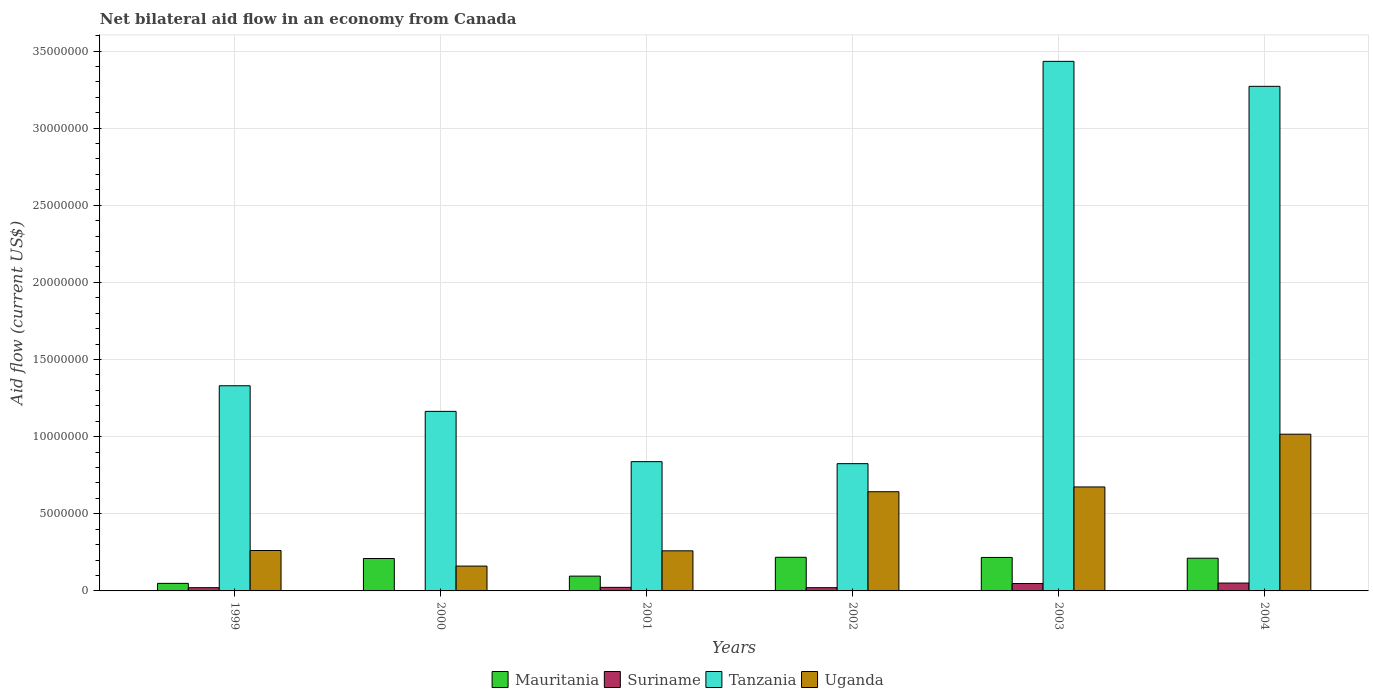Are the number of bars on each tick of the X-axis equal?
Provide a short and direct response. Yes. What is the label of the 1st group of bars from the left?
Keep it short and to the point. 1999. Across all years, what is the maximum net bilateral aid flow in Mauritania?
Offer a very short reply. 2.18e+06. In which year was the net bilateral aid flow in Tanzania minimum?
Make the answer very short. 2002. What is the total net bilateral aid flow in Suriname in the graph?
Provide a short and direct response. 1.65e+06. What is the difference between the net bilateral aid flow in Mauritania in 2001 and that in 2003?
Make the answer very short. -1.21e+06. What is the difference between the net bilateral aid flow in Suriname in 2001 and the net bilateral aid flow in Mauritania in 2002?
Give a very brief answer. -1.95e+06. What is the average net bilateral aid flow in Tanzania per year?
Ensure brevity in your answer.  1.81e+07. In the year 2000, what is the difference between the net bilateral aid flow in Mauritania and net bilateral aid flow in Suriname?
Make the answer very short. 2.09e+06. What is the ratio of the net bilateral aid flow in Mauritania in 2000 to that in 2001?
Give a very brief answer. 2.19. Is the net bilateral aid flow in Mauritania in 1999 less than that in 2001?
Give a very brief answer. Yes. What is the difference between the highest and the second highest net bilateral aid flow in Uganda?
Make the answer very short. 3.42e+06. What is the difference between the highest and the lowest net bilateral aid flow in Mauritania?
Your answer should be very brief. 1.69e+06. Is the sum of the net bilateral aid flow in Suriname in 2000 and 2002 greater than the maximum net bilateral aid flow in Mauritania across all years?
Ensure brevity in your answer.  No. What does the 2nd bar from the left in 2004 represents?
Give a very brief answer. Suriname. What does the 1st bar from the right in 2002 represents?
Ensure brevity in your answer.  Uganda. Is it the case that in every year, the sum of the net bilateral aid flow in Uganda and net bilateral aid flow in Mauritania is greater than the net bilateral aid flow in Tanzania?
Provide a succinct answer. No. How many bars are there?
Give a very brief answer. 24. Are all the bars in the graph horizontal?
Keep it short and to the point. No. What is the difference between two consecutive major ticks on the Y-axis?
Offer a very short reply. 5.00e+06. Where does the legend appear in the graph?
Make the answer very short. Bottom center. How many legend labels are there?
Ensure brevity in your answer.  4. What is the title of the graph?
Offer a very short reply. Net bilateral aid flow in an economy from Canada. Does "Iran" appear as one of the legend labels in the graph?
Ensure brevity in your answer.  No. What is the label or title of the X-axis?
Keep it short and to the point. Years. What is the label or title of the Y-axis?
Offer a very short reply. Aid flow (current US$). What is the Aid flow (current US$) of Suriname in 1999?
Give a very brief answer. 2.10e+05. What is the Aid flow (current US$) of Tanzania in 1999?
Your response must be concise. 1.33e+07. What is the Aid flow (current US$) in Uganda in 1999?
Offer a very short reply. 2.62e+06. What is the Aid flow (current US$) in Mauritania in 2000?
Your answer should be very brief. 2.10e+06. What is the Aid flow (current US$) of Tanzania in 2000?
Ensure brevity in your answer.  1.16e+07. What is the Aid flow (current US$) in Uganda in 2000?
Keep it short and to the point. 1.61e+06. What is the Aid flow (current US$) in Mauritania in 2001?
Give a very brief answer. 9.60e+05. What is the Aid flow (current US$) in Tanzania in 2001?
Your answer should be very brief. 8.38e+06. What is the Aid flow (current US$) in Uganda in 2001?
Provide a short and direct response. 2.60e+06. What is the Aid flow (current US$) in Mauritania in 2002?
Your answer should be very brief. 2.18e+06. What is the Aid flow (current US$) in Suriname in 2002?
Your answer should be very brief. 2.10e+05. What is the Aid flow (current US$) of Tanzania in 2002?
Offer a very short reply. 8.25e+06. What is the Aid flow (current US$) of Uganda in 2002?
Offer a very short reply. 6.43e+06. What is the Aid flow (current US$) in Mauritania in 2003?
Keep it short and to the point. 2.17e+06. What is the Aid flow (current US$) of Suriname in 2003?
Make the answer very short. 4.80e+05. What is the Aid flow (current US$) in Tanzania in 2003?
Provide a short and direct response. 3.43e+07. What is the Aid flow (current US$) in Uganda in 2003?
Ensure brevity in your answer.  6.74e+06. What is the Aid flow (current US$) of Mauritania in 2004?
Offer a terse response. 2.12e+06. What is the Aid flow (current US$) in Suriname in 2004?
Offer a very short reply. 5.10e+05. What is the Aid flow (current US$) of Tanzania in 2004?
Keep it short and to the point. 3.27e+07. What is the Aid flow (current US$) of Uganda in 2004?
Offer a very short reply. 1.02e+07. Across all years, what is the maximum Aid flow (current US$) of Mauritania?
Make the answer very short. 2.18e+06. Across all years, what is the maximum Aid flow (current US$) in Suriname?
Your response must be concise. 5.10e+05. Across all years, what is the maximum Aid flow (current US$) in Tanzania?
Your answer should be compact. 3.43e+07. Across all years, what is the maximum Aid flow (current US$) of Uganda?
Make the answer very short. 1.02e+07. Across all years, what is the minimum Aid flow (current US$) of Mauritania?
Your answer should be compact. 4.90e+05. Across all years, what is the minimum Aid flow (current US$) of Tanzania?
Keep it short and to the point. 8.25e+06. Across all years, what is the minimum Aid flow (current US$) in Uganda?
Give a very brief answer. 1.61e+06. What is the total Aid flow (current US$) of Mauritania in the graph?
Make the answer very short. 1.00e+07. What is the total Aid flow (current US$) in Suriname in the graph?
Make the answer very short. 1.65e+06. What is the total Aid flow (current US$) of Tanzania in the graph?
Provide a short and direct response. 1.09e+08. What is the total Aid flow (current US$) in Uganda in the graph?
Make the answer very short. 3.02e+07. What is the difference between the Aid flow (current US$) of Mauritania in 1999 and that in 2000?
Your response must be concise. -1.61e+06. What is the difference between the Aid flow (current US$) of Tanzania in 1999 and that in 2000?
Provide a short and direct response. 1.66e+06. What is the difference between the Aid flow (current US$) of Uganda in 1999 and that in 2000?
Provide a succinct answer. 1.01e+06. What is the difference between the Aid flow (current US$) of Mauritania in 1999 and that in 2001?
Your answer should be compact. -4.70e+05. What is the difference between the Aid flow (current US$) in Suriname in 1999 and that in 2001?
Make the answer very short. -2.00e+04. What is the difference between the Aid flow (current US$) of Tanzania in 1999 and that in 2001?
Ensure brevity in your answer.  4.92e+06. What is the difference between the Aid flow (current US$) of Mauritania in 1999 and that in 2002?
Make the answer very short. -1.69e+06. What is the difference between the Aid flow (current US$) of Tanzania in 1999 and that in 2002?
Give a very brief answer. 5.05e+06. What is the difference between the Aid flow (current US$) of Uganda in 1999 and that in 2002?
Ensure brevity in your answer.  -3.81e+06. What is the difference between the Aid flow (current US$) in Mauritania in 1999 and that in 2003?
Your response must be concise. -1.68e+06. What is the difference between the Aid flow (current US$) in Suriname in 1999 and that in 2003?
Give a very brief answer. -2.70e+05. What is the difference between the Aid flow (current US$) in Tanzania in 1999 and that in 2003?
Your response must be concise. -2.10e+07. What is the difference between the Aid flow (current US$) in Uganda in 1999 and that in 2003?
Make the answer very short. -4.12e+06. What is the difference between the Aid flow (current US$) of Mauritania in 1999 and that in 2004?
Offer a very short reply. -1.63e+06. What is the difference between the Aid flow (current US$) of Suriname in 1999 and that in 2004?
Offer a very short reply. -3.00e+05. What is the difference between the Aid flow (current US$) in Tanzania in 1999 and that in 2004?
Your response must be concise. -1.94e+07. What is the difference between the Aid flow (current US$) in Uganda in 1999 and that in 2004?
Offer a terse response. -7.54e+06. What is the difference between the Aid flow (current US$) in Mauritania in 2000 and that in 2001?
Ensure brevity in your answer.  1.14e+06. What is the difference between the Aid flow (current US$) in Suriname in 2000 and that in 2001?
Ensure brevity in your answer.  -2.20e+05. What is the difference between the Aid flow (current US$) in Tanzania in 2000 and that in 2001?
Offer a very short reply. 3.26e+06. What is the difference between the Aid flow (current US$) in Uganda in 2000 and that in 2001?
Your answer should be very brief. -9.90e+05. What is the difference between the Aid flow (current US$) of Mauritania in 2000 and that in 2002?
Keep it short and to the point. -8.00e+04. What is the difference between the Aid flow (current US$) in Suriname in 2000 and that in 2002?
Provide a succinct answer. -2.00e+05. What is the difference between the Aid flow (current US$) of Tanzania in 2000 and that in 2002?
Offer a very short reply. 3.39e+06. What is the difference between the Aid flow (current US$) in Uganda in 2000 and that in 2002?
Your response must be concise. -4.82e+06. What is the difference between the Aid flow (current US$) in Mauritania in 2000 and that in 2003?
Offer a very short reply. -7.00e+04. What is the difference between the Aid flow (current US$) of Suriname in 2000 and that in 2003?
Ensure brevity in your answer.  -4.70e+05. What is the difference between the Aid flow (current US$) in Tanzania in 2000 and that in 2003?
Offer a terse response. -2.27e+07. What is the difference between the Aid flow (current US$) of Uganda in 2000 and that in 2003?
Provide a short and direct response. -5.13e+06. What is the difference between the Aid flow (current US$) in Suriname in 2000 and that in 2004?
Keep it short and to the point. -5.00e+05. What is the difference between the Aid flow (current US$) of Tanzania in 2000 and that in 2004?
Offer a terse response. -2.11e+07. What is the difference between the Aid flow (current US$) in Uganda in 2000 and that in 2004?
Offer a very short reply. -8.55e+06. What is the difference between the Aid flow (current US$) of Mauritania in 2001 and that in 2002?
Provide a short and direct response. -1.22e+06. What is the difference between the Aid flow (current US$) of Suriname in 2001 and that in 2002?
Provide a succinct answer. 2.00e+04. What is the difference between the Aid flow (current US$) of Tanzania in 2001 and that in 2002?
Ensure brevity in your answer.  1.30e+05. What is the difference between the Aid flow (current US$) in Uganda in 2001 and that in 2002?
Give a very brief answer. -3.83e+06. What is the difference between the Aid flow (current US$) of Mauritania in 2001 and that in 2003?
Offer a very short reply. -1.21e+06. What is the difference between the Aid flow (current US$) of Tanzania in 2001 and that in 2003?
Your response must be concise. -2.60e+07. What is the difference between the Aid flow (current US$) in Uganda in 2001 and that in 2003?
Offer a very short reply. -4.14e+06. What is the difference between the Aid flow (current US$) of Mauritania in 2001 and that in 2004?
Offer a very short reply. -1.16e+06. What is the difference between the Aid flow (current US$) of Suriname in 2001 and that in 2004?
Keep it short and to the point. -2.80e+05. What is the difference between the Aid flow (current US$) of Tanzania in 2001 and that in 2004?
Make the answer very short. -2.43e+07. What is the difference between the Aid flow (current US$) in Uganda in 2001 and that in 2004?
Provide a short and direct response. -7.56e+06. What is the difference between the Aid flow (current US$) of Tanzania in 2002 and that in 2003?
Make the answer very short. -2.61e+07. What is the difference between the Aid flow (current US$) in Uganda in 2002 and that in 2003?
Your answer should be very brief. -3.10e+05. What is the difference between the Aid flow (current US$) of Tanzania in 2002 and that in 2004?
Offer a very short reply. -2.45e+07. What is the difference between the Aid flow (current US$) of Uganda in 2002 and that in 2004?
Make the answer very short. -3.73e+06. What is the difference between the Aid flow (current US$) in Suriname in 2003 and that in 2004?
Your answer should be compact. -3.00e+04. What is the difference between the Aid flow (current US$) in Tanzania in 2003 and that in 2004?
Your answer should be compact. 1.62e+06. What is the difference between the Aid flow (current US$) of Uganda in 2003 and that in 2004?
Ensure brevity in your answer.  -3.42e+06. What is the difference between the Aid flow (current US$) of Mauritania in 1999 and the Aid flow (current US$) of Suriname in 2000?
Provide a succinct answer. 4.80e+05. What is the difference between the Aid flow (current US$) in Mauritania in 1999 and the Aid flow (current US$) in Tanzania in 2000?
Your response must be concise. -1.12e+07. What is the difference between the Aid flow (current US$) in Mauritania in 1999 and the Aid flow (current US$) in Uganda in 2000?
Make the answer very short. -1.12e+06. What is the difference between the Aid flow (current US$) of Suriname in 1999 and the Aid flow (current US$) of Tanzania in 2000?
Provide a short and direct response. -1.14e+07. What is the difference between the Aid flow (current US$) in Suriname in 1999 and the Aid flow (current US$) in Uganda in 2000?
Provide a short and direct response. -1.40e+06. What is the difference between the Aid flow (current US$) of Tanzania in 1999 and the Aid flow (current US$) of Uganda in 2000?
Your answer should be very brief. 1.17e+07. What is the difference between the Aid flow (current US$) of Mauritania in 1999 and the Aid flow (current US$) of Suriname in 2001?
Keep it short and to the point. 2.60e+05. What is the difference between the Aid flow (current US$) of Mauritania in 1999 and the Aid flow (current US$) of Tanzania in 2001?
Your answer should be compact. -7.89e+06. What is the difference between the Aid flow (current US$) of Mauritania in 1999 and the Aid flow (current US$) of Uganda in 2001?
Give a very brief answer. -2.11e+06. What is the difference between the Aid flow (current US$) of Suriname in 1999 and the Aid flow (current US$) of Tanzania in 2001?
Offer a very short reply. -8.17e+06. What is the difference between the Aid flow (current US$) of Suriname in 1999 and the Aid flow (current US$) of Uganda in 2001?
Provide a short and direct response. -2.39e+06. What is the difference between the Aid flow (current US$) in Tanzania in 1999 and the Aid flow (current US$) in Uganda in 2001?
Ensure brevity in your answer.  1.07e+07. What is the difference between the Aid flow (current US$) in Mauritania in 1999 and the Aid flow (current US$) in Tanzania in 2002?
Ensure brevity in your answer.  -7.76e+06. What is the difference between the Aid flow (current US$) of Mauritania in 1999 and the Aid flow (current US$) of Uganda in 2002?
Ensure brevity in your answer.  -5.94e+06. What is the difference between the Aid flow (current US$) in Suriname in 1999 and the Aid flow (current US$) in Tanzania in 2002?
Provide a short and direct response. -8.04e+06. What is the difference between the Aid flow (current US$) in Suriname in 1999 and the Aid flow (current US$) in Uganda in 2002?
Provide a succinct answer. -6.22e+06. What is the difference between the Aid flow (current US$) of Tanzania in 1999 and the Aid flow (current US$) of Uganda in 2002?
Keep it short and to the point. 6.87e+06. What is the difference between the Aid flow (current US$) in Mauritania in 1999 and the Aid flow (current US$) in Tanzania in 2003?
Give a very brief answer. -3.38e+07. What is the difference between the Aid flow (current US$) in Mauritania in 1999 and the Aid flow (current US$) in Uganda in 2003?
Ensure brevity in your answer.  -6.25e+06. What is the difference between the Aid flow (current US$) in Suriname in 1999 and the Aid flow (current US$) in Tanzania in 2003?
Give a very brief answer. -3.41e+07. What is the difference between the Aid flow (current US$) in Suriname in 1999 and the Aid flow (current US$) in Uganda in 2003?
Keep it short and to the point. -6.53e+06. What is the difference between the Aid flow (current US$) of Tanzania in 1999 and the Aid flow (current US$) of Uganda in 2003?
Keep it short and to the point. 6.56e+06. What is the difference between the Aid flow (current US$) of Mauritania in 1999 and the Aid flow (current US$) of Suriname in 2004?
Give a very brief answer. -2.00e+04. What is the difference between the Aid flow (current US$) of Mauritania in 1999 and the Aid flow (current US$) of Tanzania in 2004?
Offer a very short reply. -3.22e+07. What is the difference between the Aid flow (current US$) of Mauritania in 1999 and the Aid flow (current US$) of Uganda in 2004?
Give a very brief answer. -9.67e+06. What is the difference between the Aid flow (current US$) of Suriname in 1999 and the Aid flow (current US$) of Tanzania in 2004?
Your answer should be very brief. -3.25e+07. What is the difference between the Aid flow (current US$) of Suriname in 1999 and the Aid flow (current US$) of Uganda in 2004?
Give a very brief answer. -9.95e+06. What is the difference between the Aid flow (current US$) in Tanzania in 1999 and the Aid flow (current US$) in Uganda in 2004?
Your answer should be compact. 3.14e+06. What is the difference between the Aid flow (current US$) of Mauritania in 2000 and the Aid flow (current US$) of Suriname in 2001?
Offer a terse response. 1.87e+06. What is the difference between the Aid flow (current US$) of Mauritania in 2000 and the Aid flow (current US$) of Tanzania in 2001?
Your answer should be very brief. -6.28e+06. What is the difference between the Aid flow (current US$) in Mauritania in 2000 and the Aid flow (current US$) in Uganda in 2001?
Your response must be concise. -5.00e+05. What is the difference between the Aid flow (current US$) of Suriname in 2000 and the Aid flow (current US$) of Tanzania in 2001?
Ensure brevity in your answer.  -8.37e+06. What is the difference between the Aid flow (current US$) of Suriname in 2000 and the Aid flow (current US$) of Uganda in 2001?
Your answer should be compact. -2.59e+06. What is the difference between the Aid flow (current US$) in Tanzania in 2000 and the Aid flow (current US$) in Uganda in 2001?
Your answer should be very brief. 9.04e+06. What is the difference between the Aid flow (current US$) in Mauritania in 2000 and the Aid flow (current US$) in Suriname in 2002?
Give a very brief answer. 1.89e+06. What is the difference between the Aid flow (current US$) in Mauritania in 2000 and the Aid flow (current US$) in Tanzania in 2002?
Offer a very short reply. -6.15e+06. What is the difference between the Aid flow (current US$) in Mauritania in 2000 and the Aid flow (current US$) in Uganda in 2002?
Offer a terse response. -4.33e+06. What is the difference between the Aid flow (current US$) in Suriname in 2000 and the Aid flow (current US$) in Tanzania in 2002?
Offer a terse response. -8.24e+06. What is the difference between the Aid flow (current US$) in Suriname in 2000 and the Aid flow (current US$) in Uganda in 2002?
Your response must be concise. -6.42e+06. What is the difference between the Aid flow (current US$) of Tanzania in 2000 and the Aid flow (current US$) of Uganda in 2002?
Provide a succinct answer. 5.21e+06. What is the difference between the Aid flow (current US$) in Mauritania in 2000 and the Aid flow (current US$) in Suriname in 2003?
Offer a very short reply. 1.62e+06. What is the difference between the Aid flow (current US$) of Mauritania in 2000 and the Aid flow (current US$) of Tanzania in 2003?
Provide a succinct answer. -3.22e+07. What is the difference between the Aid flow (current US$) in Mauritania in 2000 and the Aid flow (current US$) in Uganda in 2003?
Offer a terse response. -4.64e+06. What is the difference between the Aid flow (current US$) in Suriname in 2000 and the Aid flow (current US$) in Tanzania in 2003?
Keep it short and to the point. -3.43e+07. What is the difference between the Aid flow (current US$) in Suriname in 2000 and the Aid flow (current US$) in Uganda in 2003?
Your response must be concise. -6.73e+06. What is the difference between the Aid flow (current US$) of Tanzania in 2000 and the Aid flow (current US$) of Uganda in 2003?
Provide a short and direct response. 4.90e+06. What is the difference between the Aid flow (current US$) of Mauritania in 2000 and the Aid flow (current US$) of Suriname in 2004?
Your answer should be compact. 1.59e+06. What is the difference between the Aid flow (current US$) of Mauritania in 2000 and the Aid flow (current US$) of Tanzania in 2004?
Ensure brevity in your answer.  -3.06e+07. What is the difference between the Aid flow (current US$) in Mauritania in 2000 and the Aid flow (current US$) in Uganda in 2004?
Offer a very short reply. -8.06e+06. What is the difference between the Aid flow (current US$) of Suriname in 2000 and the Aid flow (current US$) of Tanzania in 2004?
Offer a terse response. -3.27e+07. What is the difference between the Aid flow (current US$) in Suriname in 2000 and the Aid flow (current US$) in Uganda in 2004?
Make the answer very short. -1.02e+07. What is the difference between the Aid flow (current US$) of Tanzania in 2000 and the Aid flow (current US$) of Uganda in 2004?
Your answer should be very brief. 1.48e+06. What is the difference between the Aid flow (current US$) in Mauritania in 2001 and the Aid flow (current US$) in Suriname in 2002?
Provide a succinct answer. 7.50e+05. What is the difference between the Aid flow (current US$) in Mauritania in 2001 and the Aid flow (current US$) in Tanzania in 2002?
Give a very brief answer. -7.29e+06. What is the difference between the Aid flow (current US$) of Mauritania in 2001 and the Aid flow (current US$) of Uganda in 2002?
Keep it short and to the point. -5.47e+06. What is the difference between the Aid flow (current US$) of Suriname in 2001 and the Aid flow (current US$) of Tanzania in 2002?
Ensure brevity in your answer.  -8.02e+06. What is the difference between the Aid flow (current US$) of Suriname in 2001 and the Aid flow (current US$) of Uganda in 2002?
Provide a short and direct response. -6.20e+06. What is the difference between the Aid flow (current US$) in Tanzania in 2001 and the Aid flow (current US$) in Uganda in 2002?
Provide a short and direct response. 1.95e+06. What is the difference between the Aid flow (current US$) of Mauritania in 2001 and the Aid flow (current US$) of Tanzania in 2003?
Offer a terse response. -3.34e+07. What is the difference between the Aid flow (current US$) in Mauritania in 2001 and the Aid flow (current US$) in Uganda in 2003?
Your response must be concise. -5.78e+06. What is the difference between the Aid flow (current US$) in Suriname in 2001 and the Aid flow (current US$) in Tanzania in 2003?
Keep it short and to the point. -3.41e+07. What is the difference between the Aid flow (current US$) in Suriname in 2001 and the Aid flow (current US$) in Uganda in 2003?
Provide a short and direct response. -6.51e+06. What is the difference between the Aid flow (current US$) in Tanzania in 2001 and the Aid flow (current US$) in Uganda in 2003?
Offer a very short reply. 1.64e+06. What is the difference between the Aid flow (current US$) in Mauritania in 2001 and the Aid flow (current US$) in Suriname in 2004?
Offer a terse response. 4.50e+05. What is the difference between the Aid flow (current US$) in Mauritania in 2001 and the Aid flow (current US$) in Tanzania in 2004?
Offer a very short reply. -3.18e+07. What is the difference between the Aid flow (current US$) of Mauritania in 2001 and the Aid flow (current US$) of Uganda in 2004?
Your answer should be very brief. -9.20e+06. What is the difference between the Aid flow (current US$) of Suriname in 2001 and the Aid flow (current US$) of Tanzania in 2004?
Offer a very short reply. -3.25e+07. What is the difference between the Aid flow (current US$) of Suriname in 2001 and the Aid flow (current US$) of Uganda in 2004?
Provide a succinct answer. -9.93e+06. What is the difference between the Aid flow (current US$) in Tanzania in 2001 and the Aid flow (current US$) in Uganda in 2004?
Keep it short and to the point. -1.78e+06. What is the difference between the Aid flow (current US$) in Mauritania in 2002 and the Aid flow (current US$) in Suriname in 2003?
Your answer should be compact. 1.70e+06. What is the difference between the Aid flow (current US$) of Mauritania in 2002 and the Aid flow (current US$) of Tanzania in 2003?
Provide a succinct answer. -3.22e+07. What is the difference between the Aid flow (current US$) in Mauritania in 2002 and the Aid flow (current US$) in Uganda in 2003?
Give a very brief answer. -4.56e+06. What is the difference between the Aid flow (current US$) of Suriname in 2002 and the Aid flow (current US$) of Tanzania in 2003?
Make the answer very short. -3.41e+07. What is the difference between the Aid flow (current US$) in Suriname in 2002 and the Aid flow (current US$) in Uganda in 2003?
Provide a succinct answer. -6.53e+06. What is the difference between the Aid flow (current US$) of Tanzania in 2002 and the Aid flow (current US$) of Uganda in 2003?
Your answer should be very brief. 1.51e+06. What is the difference between the Aid flow (current US$) of Mauritania in 2002 and the Aid flow (current US$) of Suriname in 2004?
Provide a succinct answer. 1.67e+06. What is the difference between the Aid flow (current US$) of Mauritania in 2002 and the Aid flow (current US$) of Tanzania in 2004?
Make the answer very short. -3.05e+07. What is the difference between the Aid flow (current US$) of Mauritania in 2002 and the Aid flow (current US$) of Uganda in 2004?
Provide a short and direct response. -7.98e+06. What is the difference between the Aid flow (current US$) of Suriname in 2002 and the Aid flow (current US$) of Tanzania in 2004?
Keep it short and to the point. -3.25e+07. What is the difference between the Aid flow (current US$) of Suriname in 2002 and the Aid flow (current US$) of Uganda in 2004?
Offer a very short reply. -9.95e+06. What is the difference between the Aid flow (current US$) in Tanzania in 2002 and the Aid flow (current US$) in Uganda in 2004?
Provide a succinct answer. -1.91e+06. What is the difference between the Aid flow (current US$) of Mauritania in 2003 and the Aid flow (current US$) of Suriname in 2004?
Ensure brevity in your answer.  1.66e+06. What is the difference between the Aid flow (current US$) of Mauritania in 2003 and the Aid flow (current US$) of Tanzania in 2004?
Ensure brevity in your answer.  -3.05e+07. What is the difference between the Aid flow (current US$) in Mauritania in 2003 and the Aid flow (current US$) in Uganda in 2004?
Your answer should be compact. -7.99e+06. What is the difference between the Aid flow (current US$) of Suriname in 2003 and the Aid flow (current US$) of Tanzania in 2004?
Provide a short and direct response. -3.22e+07. What is the difference between the Aid flow (current US$) in Suriname in 2003 and the Aid flow (current US$) in Uganda in 2004?
Keep it short and to the point. -9.68e+06. What is the difference between the Aid flow (current US$) in Tanzania in 2003 and the Aid flow (current US$) in Uganda in 2004?
Your answer should be compact. 2.42e+07. What is the average Aid flow (current US$) of Mauritania per year?
Offer a terse response. 1.67e+06. What is the average Aid flow (current US$) of Suriname per year?
Keep it short and to the point. 2.75e+05. What is the average Aid flow (current US$) in Tanzania per year?
Offer a very short reply. 1.81e+07. What is the average Aid flow (current US$) in Uganda per year?
Provide a short and direct response. 5.03e+06. In the year 1999, what is the difference between the Aid flow (current US$) in Mauritania and Aid flow (current US$) in Suriname?
Your response must be concise. 2.80e+05. In the year 1999, what is the difference between the Aid flow (current US$) in Mauritania and Aid flow (current US$) in Tanzania?
Your answer should be compact. -1.28e+07. In the year 1999, what is the difference between the Aid flow (current US$) in Mauritania and Aid flow (current US$) in Uganda?
Offer a very short reply. -2.13e+06. In the year 1999, what is the difference between the Aid flow (current US$) of Suriname and Aid flow (current US$) of Tanzania?
Ensure brevity in your answer.  -1.31e+07. In the year 1999, what is the difference between the Aid flow (current US$) in Suriname and Aid flow (current US$) in Uganda?
Your answer should be very brief. -2.41e+06. In the year 1999, what is the difference between the Aid flow (current US$) in Tanzania and Aid flow (current US$) in Uganda?
Provide a succinct answer. 1.07e+07. In the year 2000, what is the difference between the Aid flow (current US$) in Mauritania and Aid flow (current US$) in Suriname?
Offer a very short reply. 2.09e+06. In the year 2000, what is the difference between the Aid flow (current US$) in Mauritania and Aid flow (current US$) in Tanzania?
Your answer should be compact. -9.54e+06. In the year 2000, what is the difference between the Aid flow (current US$) in Suriname and Aid flow (current US$) in Tanzania?
Offer a very short reply. -1.16e+07. In the year 2000, what is the difference between the Aid flow (current US$) of Suriname and Aid flow (current US$) of Uganda?
Your answer should be very brief. -1.60e+06. In the year 2000, what is the difference between the Aid flow (current US$) of Tanzania and Aid flow (current US$) of Uganda?
Your answer should be very brief. 1.00e+07. In the year 2001, what is the difference between the Aid flow (current US$) of Mauritania and Aid flow (current US$) of Suriname?
Offer a very short reply. 7.30e+05. In the year 2001, what is the difference between the Aid flow (current US$) of Mauritania and Aid flow (current US$) of Tanzania?
Provide a succinct answer. -7.42e+06. In the year 2001, what is the difference between the Aid flow (current US$) of Mauritania and Aid flow (current US$) of Uganda?
Make the answer very short. -1.64e+06. In the year 2001, what is the difference between the Aid flow (current US$) of Suriname and Aid flow (current US$) of Tanzania?
Offer a terse response. -8.15e+06. In the year 2001, what is the difference between the Aid flow (current US$) of Suriname and Aid flow (current US$) of Uganda?
Your answer should be very brief. -2.37e+06. In the year 2001, what is the difference between the Aid flow (current US$) of Tanzania and Aid flow (current US$) of Uganda?
Your answer should be compact. 5.78e+06. In the year 2002, what is the difference between the Aid flow (current US$) of Mauritania and Aid flow (current US$) of Suriname?
Offer a very short reply. 1.97e+06. In the year 2002, what is the difference between the Aid flow (current US$) of Mauritania and Aid flow (current US$) of Tanzania?
Your answer should be compact. -6.07e+06. In the year 2002, what is the difference between the Aid flow (current US$) of Mauritania and Aid flow (current US$) of Uganda?
Keep it short and to the point. -4.25e+06. In the year 2002, what is the difference between the Aid flow (current US$) in Suriname and Aid flow (current US$) in Tanzania?
Provide a succinct answer. -8.04e+06. In the year 2002, what is the difference between the Aid flow (current US$) of Suriname and Aid flow (current US$) of Uganda?
Provide a succinct answer. -6.22e+06. In the year 2002, what is the difference between the Aid flow (current US$) of Tanzania and Aid flow (current US$) of Uganda?
Your answer should be compact. 1.82e+06. In the year 2003, what is the difference between the Aid flow (current US$) in Mauritania and Aid flow (current US$) in Suriname?
Your answer should be compact. 1.69e+06. In the year 2003, what is the difference between the Aid flow (current US$) in Mauritania and Aid flow (current US$) in Tanzania?
Your answer should be very brief. -3.22e+07. In the year 2003, what is the difference between the Aid flow (current US$) in Mauritania and Aid flow (current US$) in Uganda?
Your answer should be compact. -4.57e+06. In the year 2003, what is the difference between the Aid flow (current US$) of Suriname and Aid flow (current US$) of Tanzania?
Offer a very short reply. -3.38e+07. In the year 2003, what is the difference between the Aid flow (current US$) in Suriname and Aid flow (current US$) in Uganda?
Offer a terse response. -6.26e+06. In the year 2003, what is the difference between the Aid flow (current US$) in Tanzania and Aid flow (current US$) in Uganda?
Give a very brief answer. 2.76e+07. In the year 2004, what is the difference between the Aid flow (current US$) of Mauritania and Aid flow (current US$) of Suriname?
Offer a terse response. 1.61e+06. In the year 2004, what is the difference between the Aid flow (current US$) of Mauritania and Aid flow (current US$) of Tanzania?
Your answer should be compact. -3.06e+07. In the year 2004, what is the difference between the Aid flow (current US$) in Mauritania and Aid flow (current US$) in Uganda?
Provide a succinct answer. -8.04e+06. In the year 2004, what is the difference between the Aid flow (current US$) in Suriname and Aid flow (current US$) in Tanzania?
Keep it short and to the point. -3.22e+07. In the year 2004, what is the difference between the Aid flow (current US$) of Suriname and Aid flow (current US$) of Uganda?
Ensure brevity in your answer.  -9.65e+06. In the year 2004, what is the difference between the Aid flow (current US$) of Tanzania and Aid flow (current US$) of Uganda?
Make the answer very short. 2.26e+07. What is the ratio of the Aid flow (current US$) in Mauritania in 1999 to that in 2000?
Ensure brevity in your answer.  0.23. What is the ratio of the Aid flow (current US$) in Suriname in 1999 to that in 2000?
Offer a very short reply. 21. What is the ratio of the Aid flow (current US$) in Tanzania in 1999 to that in 2000?
Provide a short and direct response. 1.14. What is the ratio of the Aid flow (current US$) of Uganda in 1999 to that in 2000?
Ensure brevity in your answer.  1.63. What is the ratio of the Aid flow (current US$) of Mauritania in 1999 to that in 2001?
Your response must be concise. 0.51. What is the ratio of the Aid flow (current US$) in Tanzania in 1999 to that in 2001?
Provide a succinct answer. 1.59. What is the ratio of the Aid flow (current US$) in Uganda in 1999 to that in 2001?
Provide a succinct answer. 1.01. What is the ratio of the Aid flow (current US$) in Mauritania in 1999 to that in 2002?
Your answer should be compact. 0.22. What is the ratio of the Aid flow (current US$) in Suriname in 1999 to that in 2002?
Offer a terse response. 1. What is the ratio of the Aid flow (current US$) in Tanzania in 1999 to that in 2002?
Keep it short and to the point. 1.61. What is the ratio of the Aid flow (current US$) of Uganda in 1999 to that in 2002?
Your answer should be compact. 0.41. What is the ratio of the Aid flow (current US$) of Mauritania in 1999 to that in 2003?
Your answer should be compact. 0.23. What is the ratio of the Aid flow (current US$) in Suriname in 1999 to that in 2003?
Offer a terse response. 0.44. What is the ratio of the Aid flow (current US$) of Tanzania in 1999 to that in 2003?
Provide a short and direct response. 0.39. What is the ratio of the Aid flow (current US$) in Uganda in 1999 to that in 2003?
Provide a short and direct response. 0.39. What is the ratio of the Aid flow (current US$) of Mauritania in 1999 to that in 2004?
Keep it short and to the point. 0.23. What is the ratio of the Aid flow (current US$) of Suriname in 1999 to that in 2004?
Provide a succinct answer. 0.41. What is the ratio of the Aid flow (current US$) in Tanzania in 1999 to that in 2004?
Your answer should be compact. 0.41. What is the ratio of the Aid flow (current US$) in Uganda in 1999 to that in 2004?
Provide a short and direct response. 0.26. What is the ratio of the Aid flow (current US$) of Mauritania in 2000 to that in 2001?
Your answer should be compact. 2.19. What is the ratio of the Aid flow (current US$) of Suriname in 2000 to that in 2001?
Your answer should be very brief. 0.04. What is the ratio of the Aid flow (current US$) in Tanzania in 2000 to that in 2001?
Offer a very short reply. 1.39. What is the ratio of the Aid flow (current US$) of Uganda in 2000 to that in 2001?
Provide a short and direct response. 0.62. What is the ratio of the Aid flow (current US$) in Mauritania in 2000 to that in 2002?
Offer a very short reply. 0.96. What is the ratio of the Aid flow (current US$) of Suriname in 2000 to that in 2002?
Ensure brevity in your answer.  0.05. What is the ratio of the Aid flow (current US$) in Tanzania in 2000 to that in 2002?
Provide a short and direct response. 1.41. What is the ratio of the Aid flow (current US$) of Uganda in 2000 to that in 2002?
Offer a terse response. 0.25. What is the ratio of the Aid flow (current US$) of Mauritania in 2000 to that in 2003?
Your response must be concise. 0.97. What is the ratio of the Aid flow (current US$) of Suriname in 2000 to that in 2003?
Your response must be concise. 0.02. What is the ratio of the Aid flow (current US$) of Tanzania in 2000 to that in 2003?
Make the answer very short. 0.34. What is the ratio of the Aid flow (current US$) of Uganda in 2000 to that in 2003?
Your response must be concise. 0.24. What is the ratio of the Aid flow (current US$) in Mauritania in 2000 to that in 2004?
Offer a terse response. 0.99. What is the ratio of the Aid flow (current US$) of Suriname in 2000 to that in 2004?
Provide a short and direct response. 0.02. What is the ratio of the Aid flow (current US$) in Tanzania in 2000 to that in 2004?
Keep it short and to the point. 0.36. What is the ratio of the Aid flow (current US$) of Uganda in 2000 to that in 2004?
Keep it short and to the point. 0.16. What is the ratio of the Aid flow (current US$) in Mauritania in 2001 to that in 2002?
Provide a short and direct response. 0.44. What is the ratio of the Aid flow (current US$) in Suriname in 2001 to that in 2002?
Offer a terse response. 1.1. What is the ratio of the Aid flow (current US$) in Tanzania in 2001 to that in 2002?
Your answer should be very brief. 1.02. What is the ratio of the Aid flow (current US$) of Uganda in 2001 to that in 2002?
Keep it short and to the point. 0.4. What is the ratio of the Aid flow (current US$) in Mauritania in 2001 to that in 2003?
Make the answer very short. 0.44. What is the ratio of the Aid flow (current US$) of Suriname in 2001 to that in 2003?
Make the answer very short. 0.48. What is the ratio of the Aid flow (current US$) of Tanzania in 2001 to that in 2003?
Make the answer very short. 0.24. What is the ratio of the Aid flow (current US$) in Uganda in 2001 to that in 2003?
Your response must be concise. 0.39. What is the ratio of the Aid flow (current US$) in Mauritania in 2001 to that in 2004?
Make the answer very short. 0.45. What is the ratio of the Aid flow (current US$) of Suriname in 2001 to that in 2004?
Your answer should be very brief. 0.45. What is the ratio of the Aid flow (current US$) of Tanzania in 2001 to that in 2004?
Provide a short and direct response. 0.26. What is the ratio of the Aid flow (current US$) of Uganda in 2001 to that in 2004?
Your answer should be compact. 0.26. What is the ratio of the Aid flow (current US$) in Mauritania in 2002 to that in 2003?
Provide a short and direct response. 1. What is the ratio of the Aid flow (current US$) of Suriname in 2002 to that in 2003?
Give a very brief answer. 0.44. What is the ratio of the Aid flow (current US$) in Tanzania in 2002 to that in 2003?
Your answer should be very brief. 0.24. What is the ratio of the Aid flow (current US$) of Uganda in 2002 to that in 2003?
Your answer should be very brief. 0.95. What is the ratio of the Aid flow (current US$) of Mauritania in 2002 to that in 2004?
Give a very brief answer. 1.03. What is the ratio of the Aid flow (current US$) in Suriname in 2002 to that in 2004?
Make the answer very short. 0.41. What is the ratio of the Aid flow (current US$) of Tanzania in 2002 to that in 2004?
Offer a very short reply. 0.25. What is the ratio of the Aid flow (current US$) of Uganda in 2002 to that in 2004?
Keep it short and to the point. 0.63. What is the ratio of the Aid flow (current US$) of Mauritania in 2003 to that in 2004?
Offer a very short reply. 1.02. What is the ratio of the Aid flow (current US$) in Suriname in 2003 to that in 2004?
Keep it short and to the point. 0.94. What is the ratio of the Aid flow (current US$) of Tanzania in 2003 to that in 2004?
Offer a very short reply. 1.05. What is the ratio of the Aid flow (current US$) in Uganda in 2003 to that in 2004?
Your answer should be compact. 0.66. What is the difference between the highest and the second highest Aid flow (current US$) of Suriname?
Make the answer very short. 3.00e+04. What is the difference between the highest and the second highest Aid flow (current US$) in Tanzania?
Your answer should be compact. 1.62e+06. What is the difference between the highest and the second highest Aid flow (current US$) in Uganda?
Offer a terse response. 3.42e+06. What is the difference between the highest and the lowest Aid flow (current US$) in Mauritania?
Provide a succinct answer. 1.69e+06. What is the difference between the highest and the lowest Aid flow (current US$) in Suriname?
Offer a terse response. 5.00e+05. What is the difference between the highest and the lowest Aid flow (current US$) of Tanzania?
Offer a terse response. 2.61e+07. What is the difference between the highest and the lowest Aid flow (current US$) of Uganda?
Give a very brief answer. 8.55e+06. 